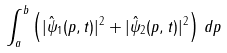Convert formula to latex. <formula><loc_0><loc_0><loc_500><loc_500>\int _ { a } ^ { b } \left ( | \hat { \psi } _ { 1 } ( p , t ) | ^ { 2 } + | \hat { \psi } _ { 2 } ( p , t ) | ^ { 2 } \right ) \, d p</formula> 